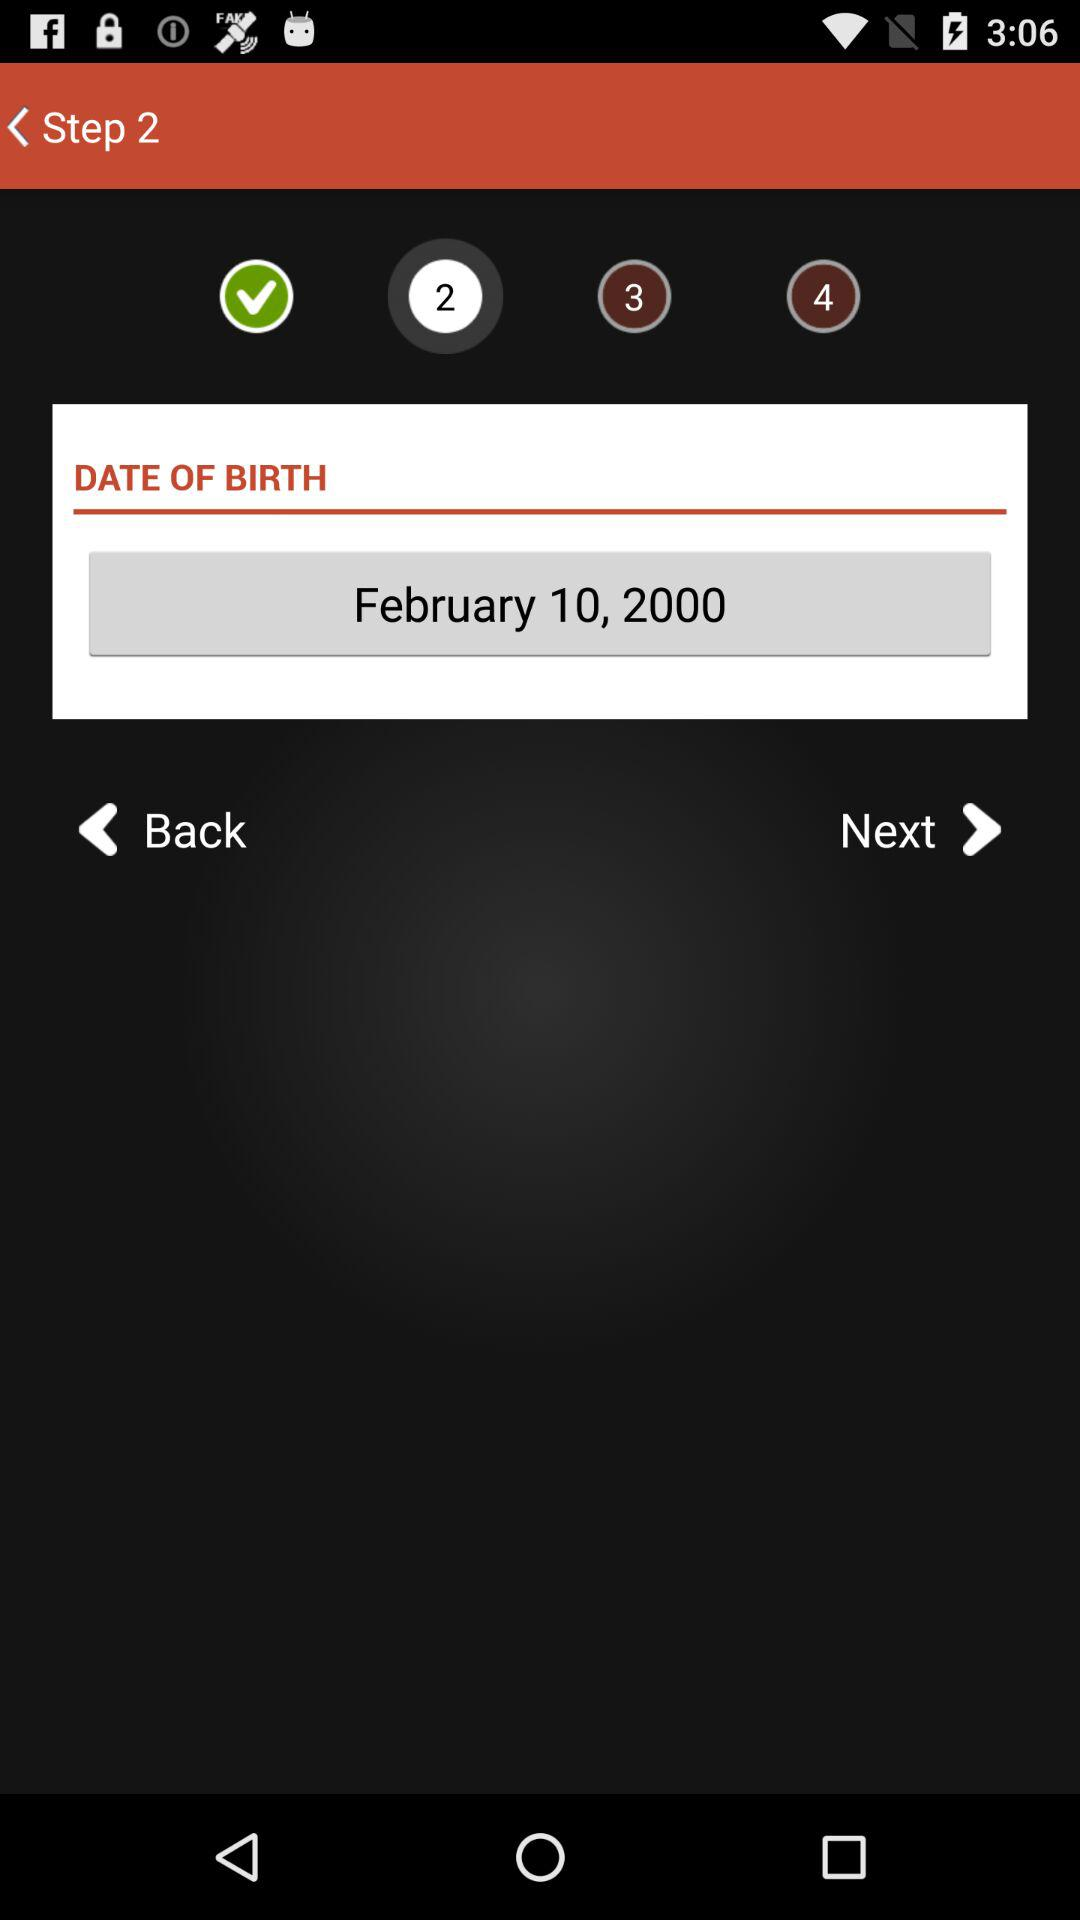How many steps are there in the registration process?
Answer the question using a single word or phrase. 4 